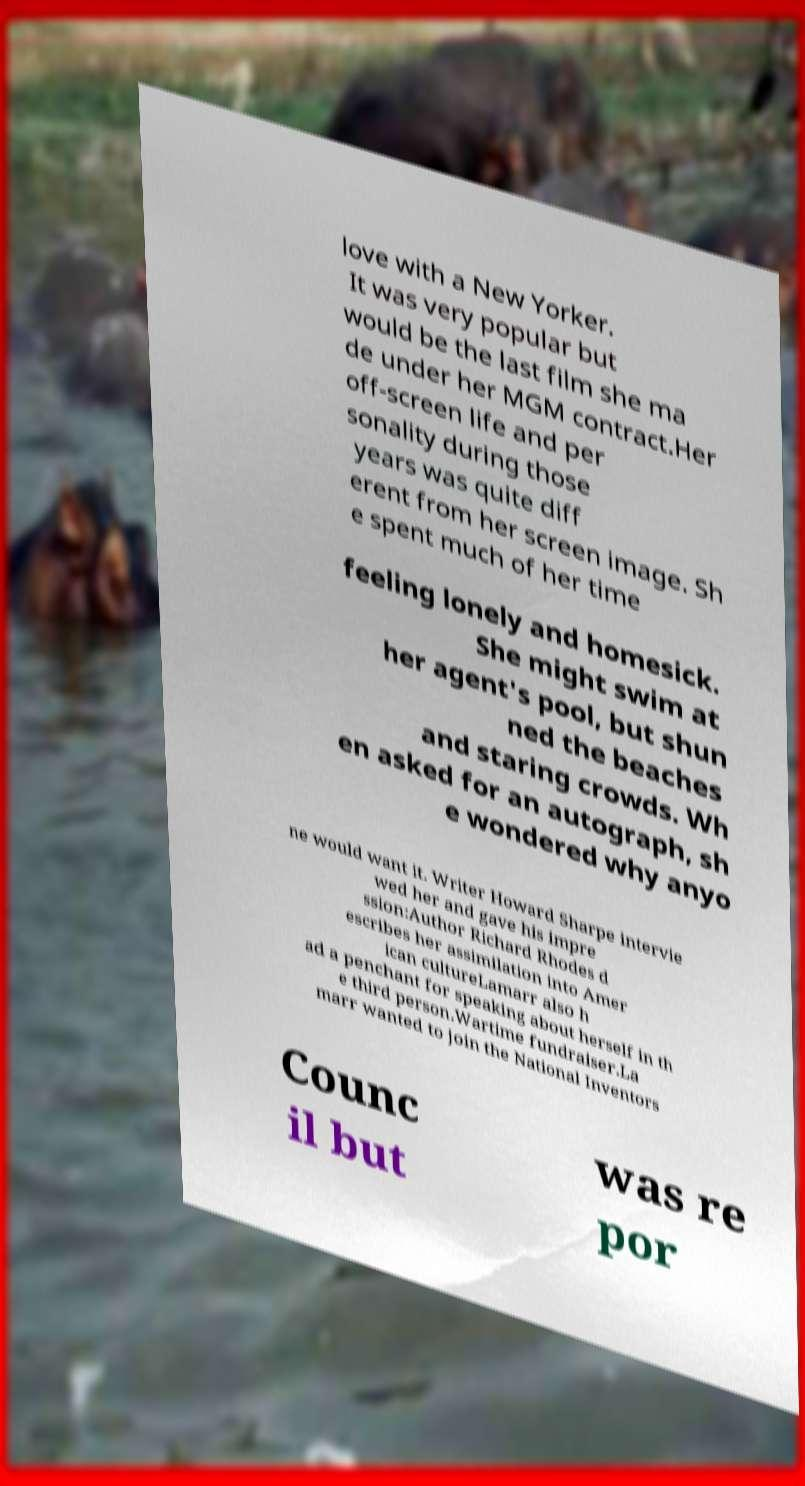Please identify and transcribe the text found in this image. love with a New Yorker. It was very popular but would be the last film she ma de under her MGM contract.Her off-screen life and per sonality during those years was quite diff erent from her screen image. Sh e spent much of her time feeling lonely and homesick. She might swim at her agent's pool, but shun ned the beaches and staring crowds. Wh en asked for an autograph, sh e wondered why anyo ne would want it. Writer Howard Sharpe intervie wed her and gave his impre ssion:Author Richard Rhodes d escribes her assimilation into Amer ican cultureLamarr also h ad a penchant for speaking about herself in th e third person.Wartime fundraiser.La marr wanted to join the National Inventors Counc il but was re por 